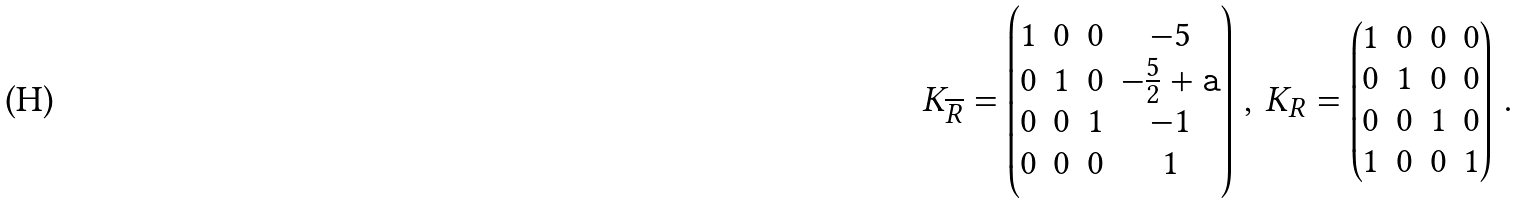<formula> <loc_0><loc_0><loc_500><loc_500>K _ { \overline { R } } = \left ( \begin{matrix} 1 & 0 & 0 & - 5 \\ 0 & 1 & 0 & - \frac { 5 } { 2 } + { \tt a } \\ 0 & 0 & 1 & - 1 \\ 0 & 0 & 0 & 1 \end{matrix} \right ) \, , \, K _ { R } = \left ( \begin{matrix} 1 & 0 & 0 & 0 \\ 0 & 1 & 0 & 0 \\ 0 & 0 & 1 & 0 \\ 1 & 0 & 0 & 1 \\ \end{matrix} \right ) \, . \,</formula> 